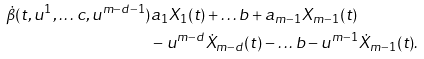<formula> <loc_0><loc_0><loc_500><loc_500>\dot { \beta } ( t , u ^ { 1 } , \dots c , u ^ { m - d - 1 } ) & a _ { 1 } X _ { 1 } ( t ) + \dots b + a _ { m - 1 } X _ { m - 1 } ( t ) \\ & - u ^ { m - d } \dot { X } _ { m - d } ( t ) - \dots b - u ^ { m - 1 } \dot { X } _ { m - 1 } ( t ) .</formula> 